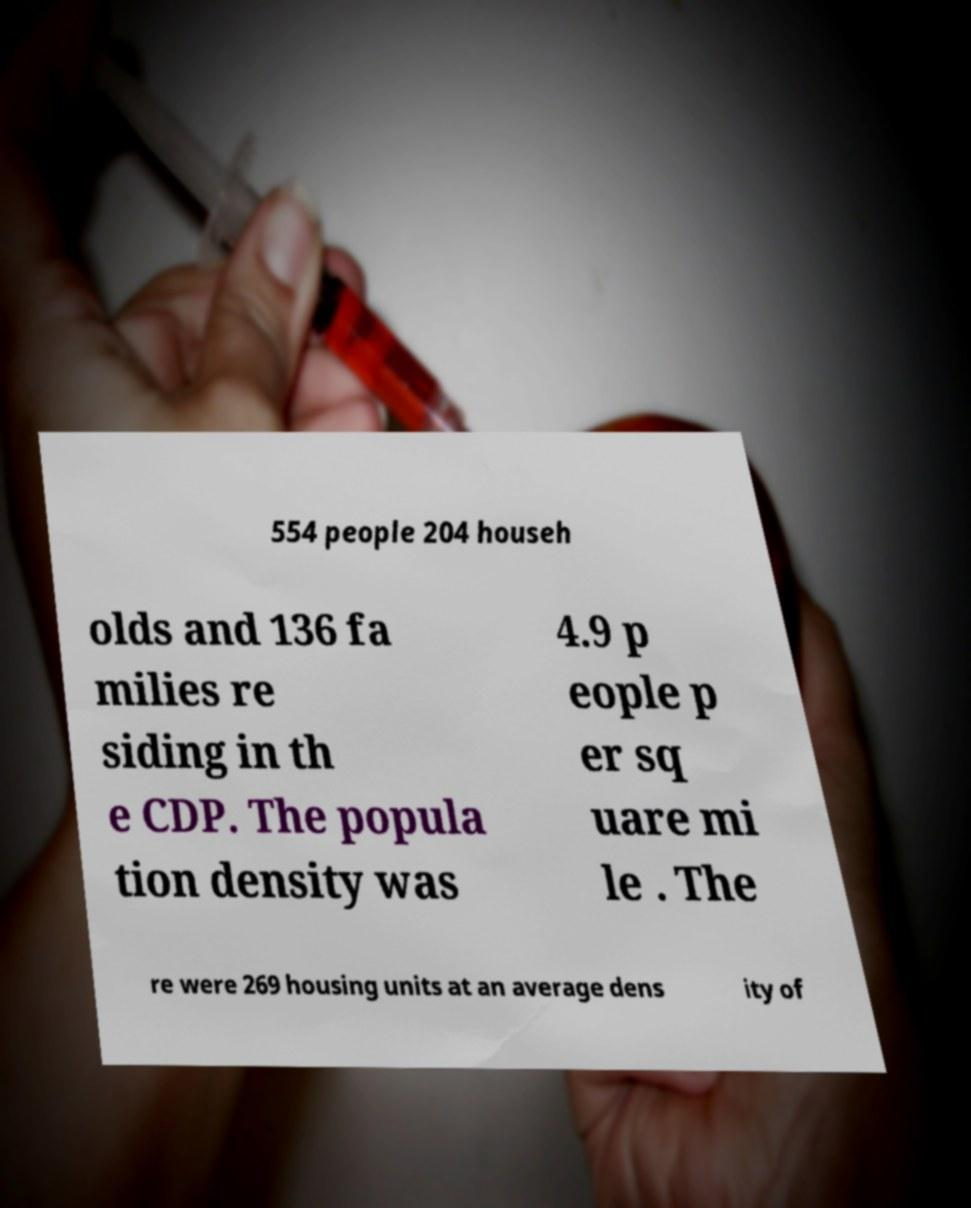Can you accurately transcribe the text from the provided image for me? 554 people 204 househ olds and 136 fa milies re siding in th e CDP. The popula tion density was 4.9 p eople p er sq uare mi le . The re were 269 housing units at an average dens ity of 